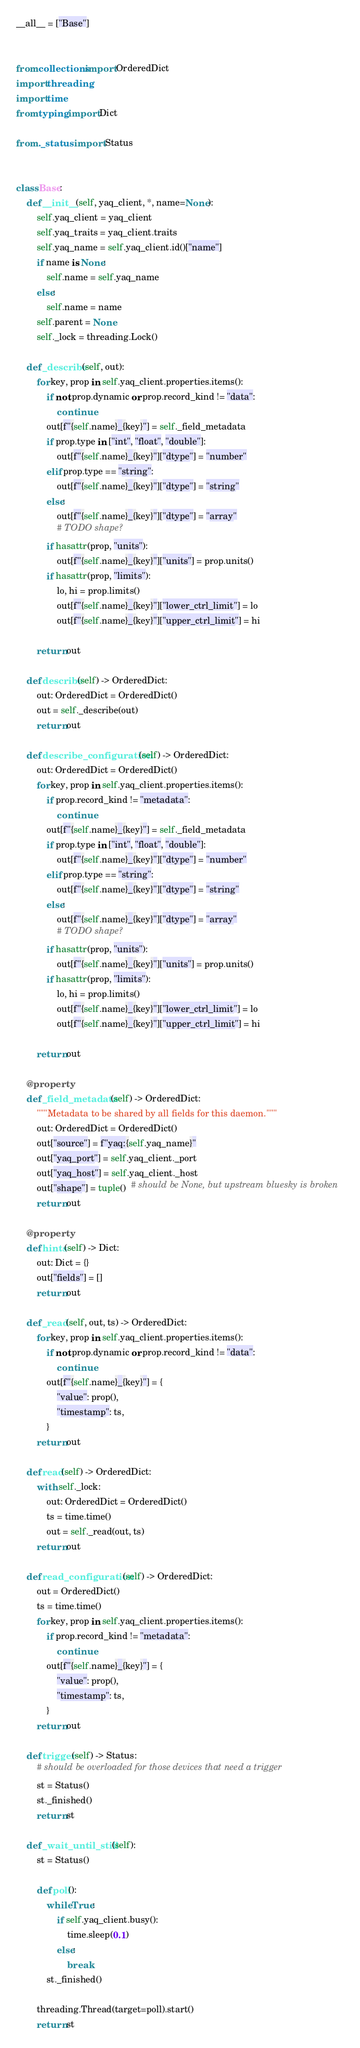<code> <loc_0><loc_0><loc_500><loc_500><_Python_>__all__ = ["Base"]


from collections import OrderedDict
import threading
import time
from typing import Dict

from ._status import Status


class Base:
    def __init__(self, yaq_client, *, name=None):
        self.yaq_client = yaq_client
        self.yaq_traits = yaq_client.traits
        self.yaq_name = self.yaq_client.id()["name"]
        if name is None:
            self.name = self.yaq_name
        else:
            self.name = name
        self.parent = None
        self._lock = threading.Lock()

    def _describe(self, out):
        for key, prop in self.yaq_client.properties.items():
            if not prop.dynamic or prop.record_kind != "data":
                continue
            out[f"{self.name}_{key}"] = self._field_metadata
            if prop.type in ["int", "float", "double"]:
                out[f"{self.name}_{key}"]["dtype"] = "number"
            elif prop.type == "string":
                out[f"{self.name}_{key}"]["dtype"] = "string"
            else:
                out[f"{self.name}_{key}"]["dtype"] = "array"
                # TODO shape?
            if hasattr(prop, "units"):
                out[f"{self.name}_{key}"]["units"] = prop.units()
            if hasattr(prop, "limits"):
                lo, hi = prop.limits()
                out[f"{self.name}_{key}"]["lower_ctrl_limit"] = lo
                out[f"{self.name}_{key}"]["upper_ctrl_limit"] = hi

        return out

    def describe(self) -> OrderedDict:
        out: OrderedDict = OrderedDict()
        out = self._describe(out)
        return out

    def describe_configuration(self) -> OrderedDict:
        out: OrderedDict = OrderedDict()
        for key, prop in self.yaq_client.properties.items():
            if prop.record_kind != "metadata":
                continue
            out[f"{self.name}_{key}"] = self._field_metadata
            if prop.type in ["int", "float", "double"]:
                out[f"{self.name}_{key}"]["dtype"] = "number"
            elif prop.type == "string":
                out[f"{self.name}_{key}"]["dtype"] = "string"
            else:
                out[f"{self.name}_{key}"]["dtype"] = "array"
                # TODO shape?
            if hasattr(prop, "units"):
                out[f"{self.name}_{key}"]["units"] = prop.units()
            if hasattr(prop, "limits"):
                lo, hi = prop.limits()
                out[f"{self.name}_{key}"]["lower_ctrl_limit"] = lo
                out[f"{self.name}_{key}"]["upper_ctrl_limit"] = hi

        return out

    @property
    def _field_metadata(self) -> OrderedDict:
        """Metadata to be shared by all fields for this daemon."""
        out: OrderedDict = OrderedDict()
        out["source"] = f"yaq:{self.yaq_name}"
        out["yaq_port"] = self.yaq_client._port
        out["yaq_host"] = self.yaq_client._host
        out["shape"] = tuple()  # should be None, but upstream bluesky is broken
        return out

    @property
    def hints(self) -> Dict:
        out: Dict = {}
        out["fields"] = []
        return out

    def _read(self, out, ts) -> OrderedDict:
        for key, prop in self.yaq_client.properties.items():
            if not prop.dynamic or prop.record_kind != "data":
                continue
            out[f"{self.name}_{key}"] = {
                "value": prop(),
                "timestamp": ts,
            }
        return out

    def read(self) -> OrderedDict:
        with self._lock:
            out: OrderedDict = OrderedDict()
            ts = time.time()
            out = self._read(out, ts)
        return out

    def read_configuration(self) -> OrderedDict:
        out = OrderedDict()
        ts = time.time()
        for key, prop in self.yaq_client.properties.items():
            if prop.record_kind != "metadata":
                continue
            out[f"{self.name}_{key}"] = {
                "value": prop(),
                "timestamp": ts,
            }
        return out

    def trigger(self) -> Status:
        # should be overloaded for those devices that need a trigger
        st = Status()
        st._finished()
        return st

    def _wait_until_still(self):
        st = Status()

        def poll():
            while True:
                if self.yaq_client.busy():
                    time.sleep(0.1)
                else:
                    break
            st._finished()

        threading.Thread(target=poll).start()
        return st
</code> 